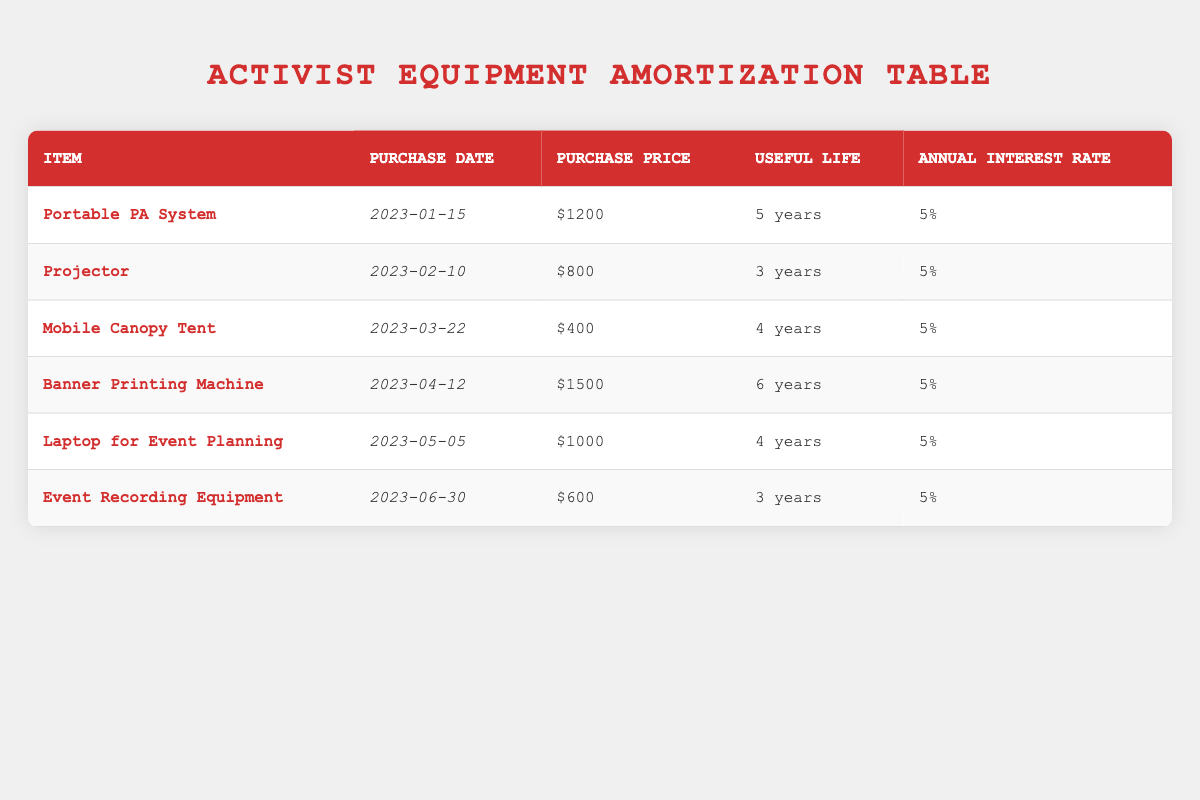What is the purchase price of the Portable PA System? The purchase price of the Portable PA System is found directly in the table under the "Purchase Price" column corresponding to the Portable PA System row. It lists the value as 1200.
Answer: 1200 How long is the useful life of the Projector? The useful life of the Projector can be found in the table under the "Useful Life" column corresponding to the Projector row, which indicates a useful life of 3 years.
Answer: 3 years What is the total purchase price of all the equipment? To find the total purchase price, sum the values in the "Purchase Price" column: 1200 + 800 + 400 + 1500 + 1000 + 600 = 4500.
Answer: 4500 Does the Laptop for Event Planning have a longer useful life than the Banner Printing Machine? The useful life of the Laptop for Event Planning is 4 years, whereas the Banner Printing Machine has a useful life of 6 years. Since 4 years is less than 6 years, the statement is false.
Answer: No Which item has the highest purchase price? To identify the item with the highest purchase price, compare all the values in the "Purchase Price" column. The values are 1200, 800, 400, 1500, 1000, and 600. The highest value is 1500 for the Banner Printing Machine.
Answer: Banner Printing Machine What is the average useful life of the equipment? To determine the average useful life, add the useful life values: 5 + 3 + 4 + 6 + 4 + 3 = 25. There are 6 items, so the average is 25 / 6 = 4.17 years.
Answer: 4.17 years Is the annual interest rate the same for all items? The table shows that the annual interest rate for all items is consistently listed as 5%, indicating that the statement is true.
Answer: Yes Which item was purchased most recently? The purchase dates in the table are listed for each item. The most recent date is "2023-06-30," which corresponds to the Event Recording Equipment.
Answer: Event Recording Equipment What is the difference in purchase price between the Portable PA System and the Mobile Canopy Tent? The purchase price of the Portable PA System is 1200, and that of the Mobile Canopy Tent is 400. To find the difference, subtract the smaller price from the larger: 1200 - 400 = 800.
Answer: 800 